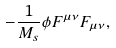Convert formula to latex. <formula><loc_0><loc_0><loc_500><loc_500>- \frac { 1 } { M _ { s } } \phi F ^ { \mu \nu } F _ { \mu \nu } ,</formula> 